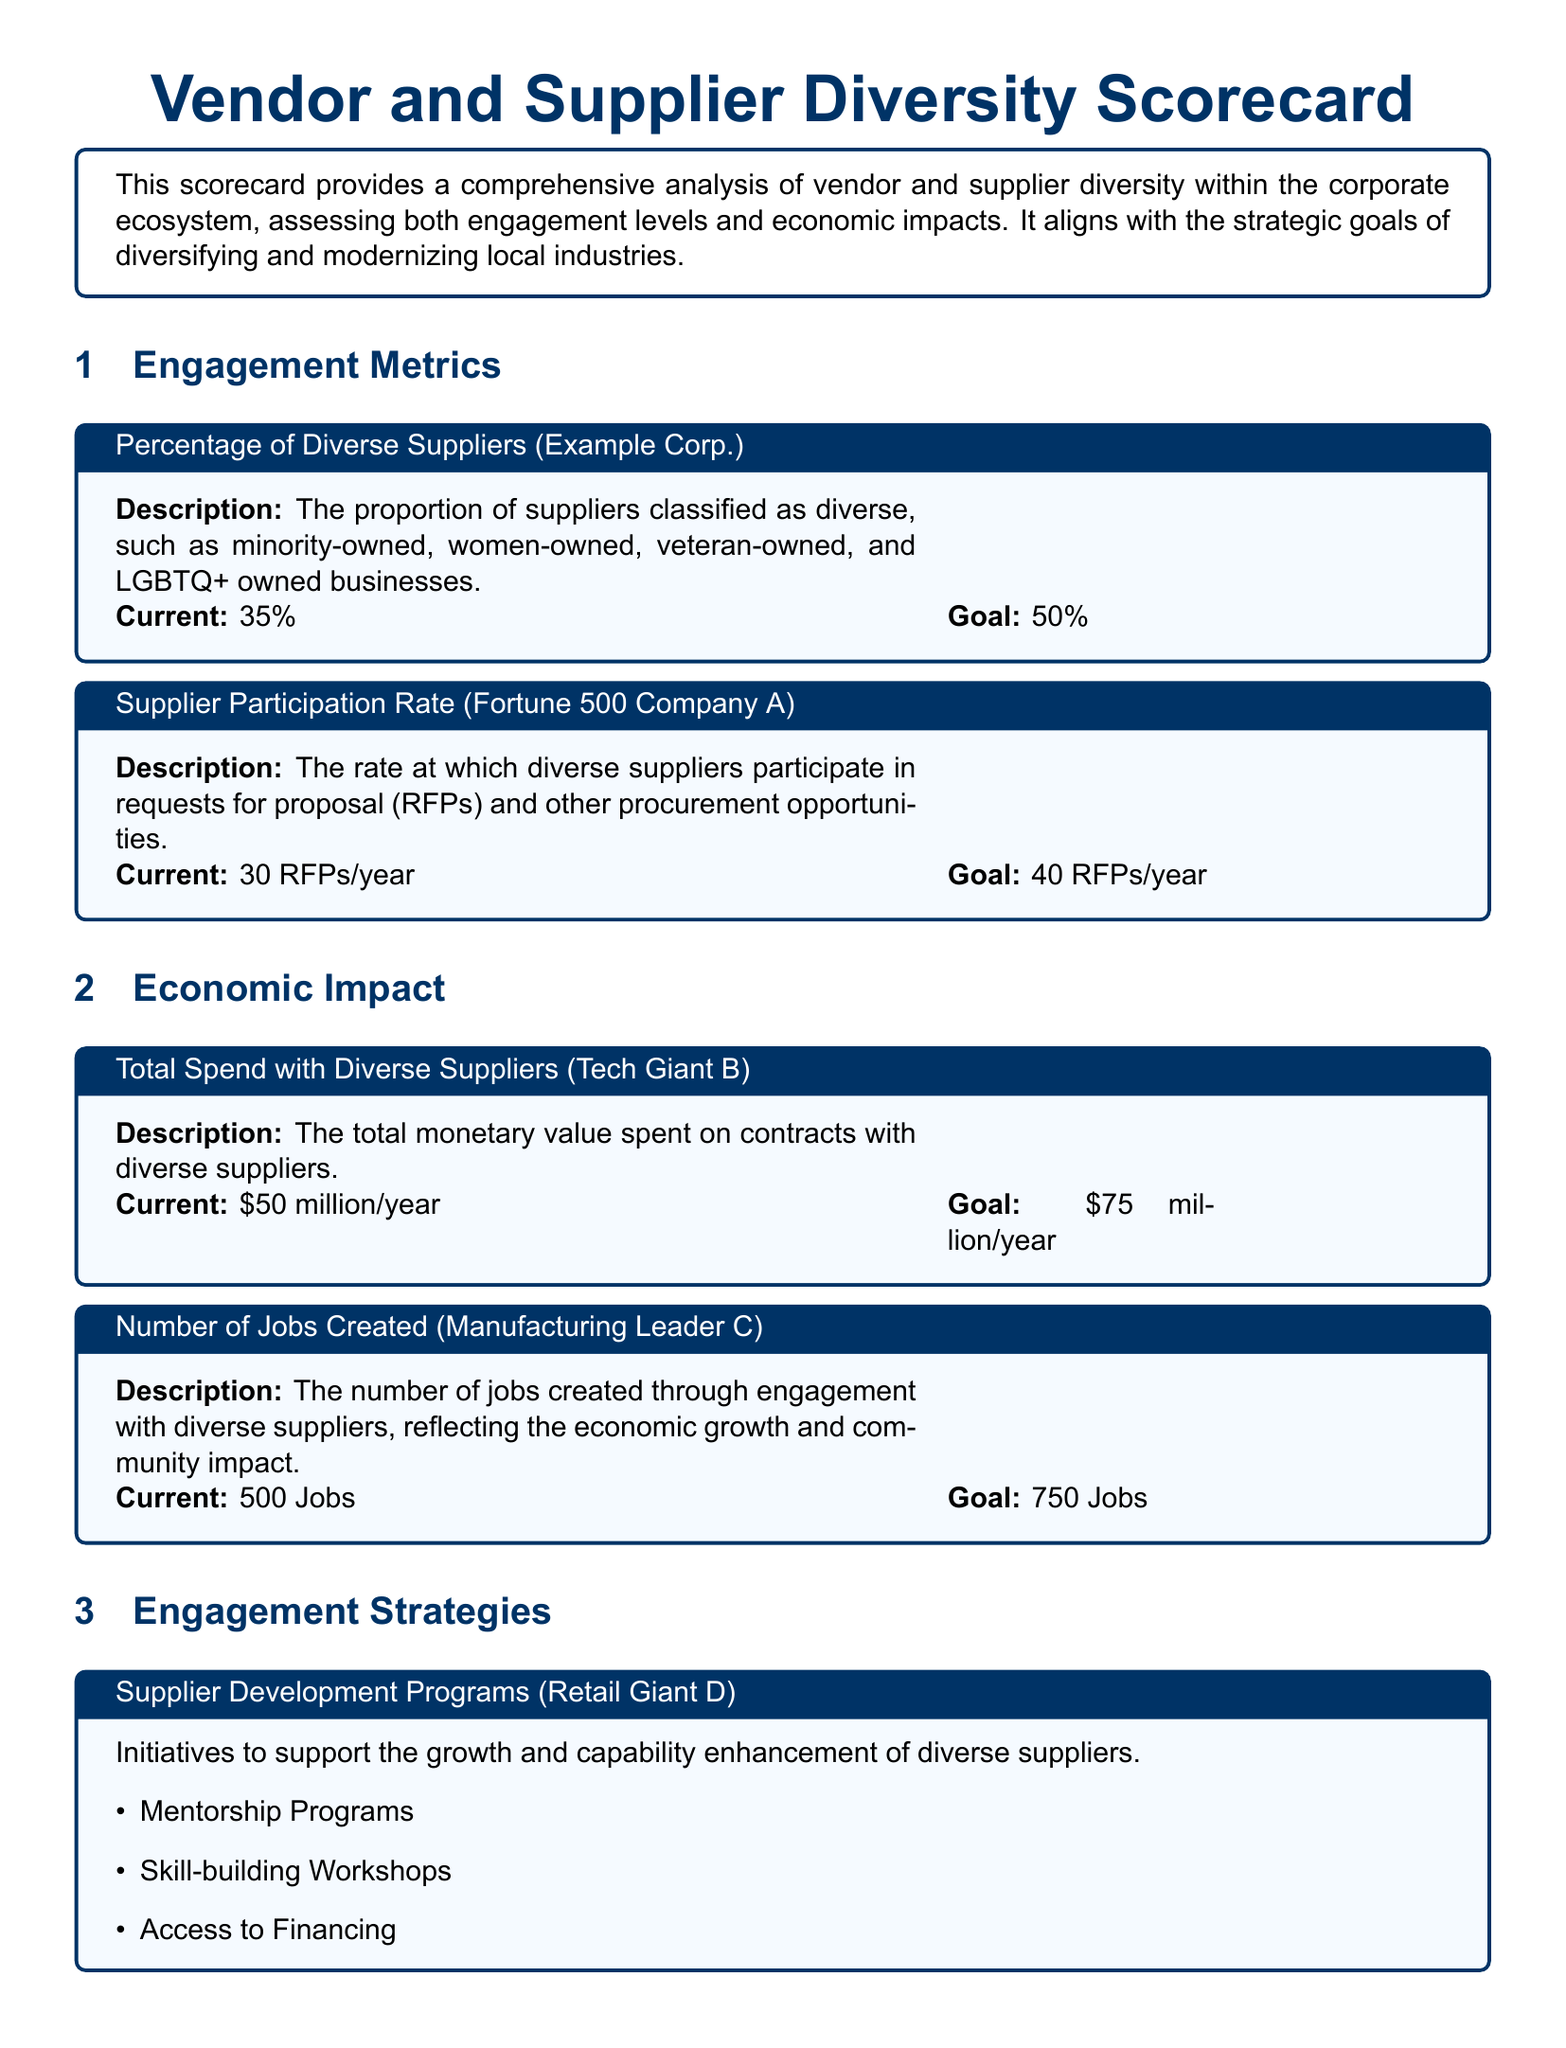What is the current percentage of diverse suppliers? The document states that the current percentage of diverse suppliers is 35%.
Answer: 35% What is the goal for the total spend with diverse suppliers? The document indicates that the goal for total spend with diverse suppliers is $75 million per year.
Answer: $75 million/year How many jobs are expected to be created through engagement with diverse suppliers? It mentions that 750 jobs are the goal to be created through engagement with diverse suppliers.
Answer: 750 Jobs What is one of the organizations mentioned for partnerships with advocacy groups? The document lists the National Minority Supplier Development Council as one of the organizations for partnerships.
Answer: National Minority Supplier Development Council What is the impact of diverse suppliers on market share according to the Healthcare Leader? The document states that diverse suppliers lead to a 15% increase in market share.
Answer: Increased Market Share by 15% How many RFPs does Fortune 500 Company A participate in currently? The current participation rate of Fortune 500 Company A in RFPs is 30 RFPs per year.
Answer: 30 RFPs/year What is one of the main goals of the Vendor and Supplier Diversity Scorecard? The main goal outlined is to advocate for and contribute to the diversification and modernization of local industries.
Answer: Diversification and modernization of local industries What type of programs does Retail Giant D implement for supplier development? The document highlights mentorship programs as part of the supplier development initiatives.
Answer: Mentorship Programs 